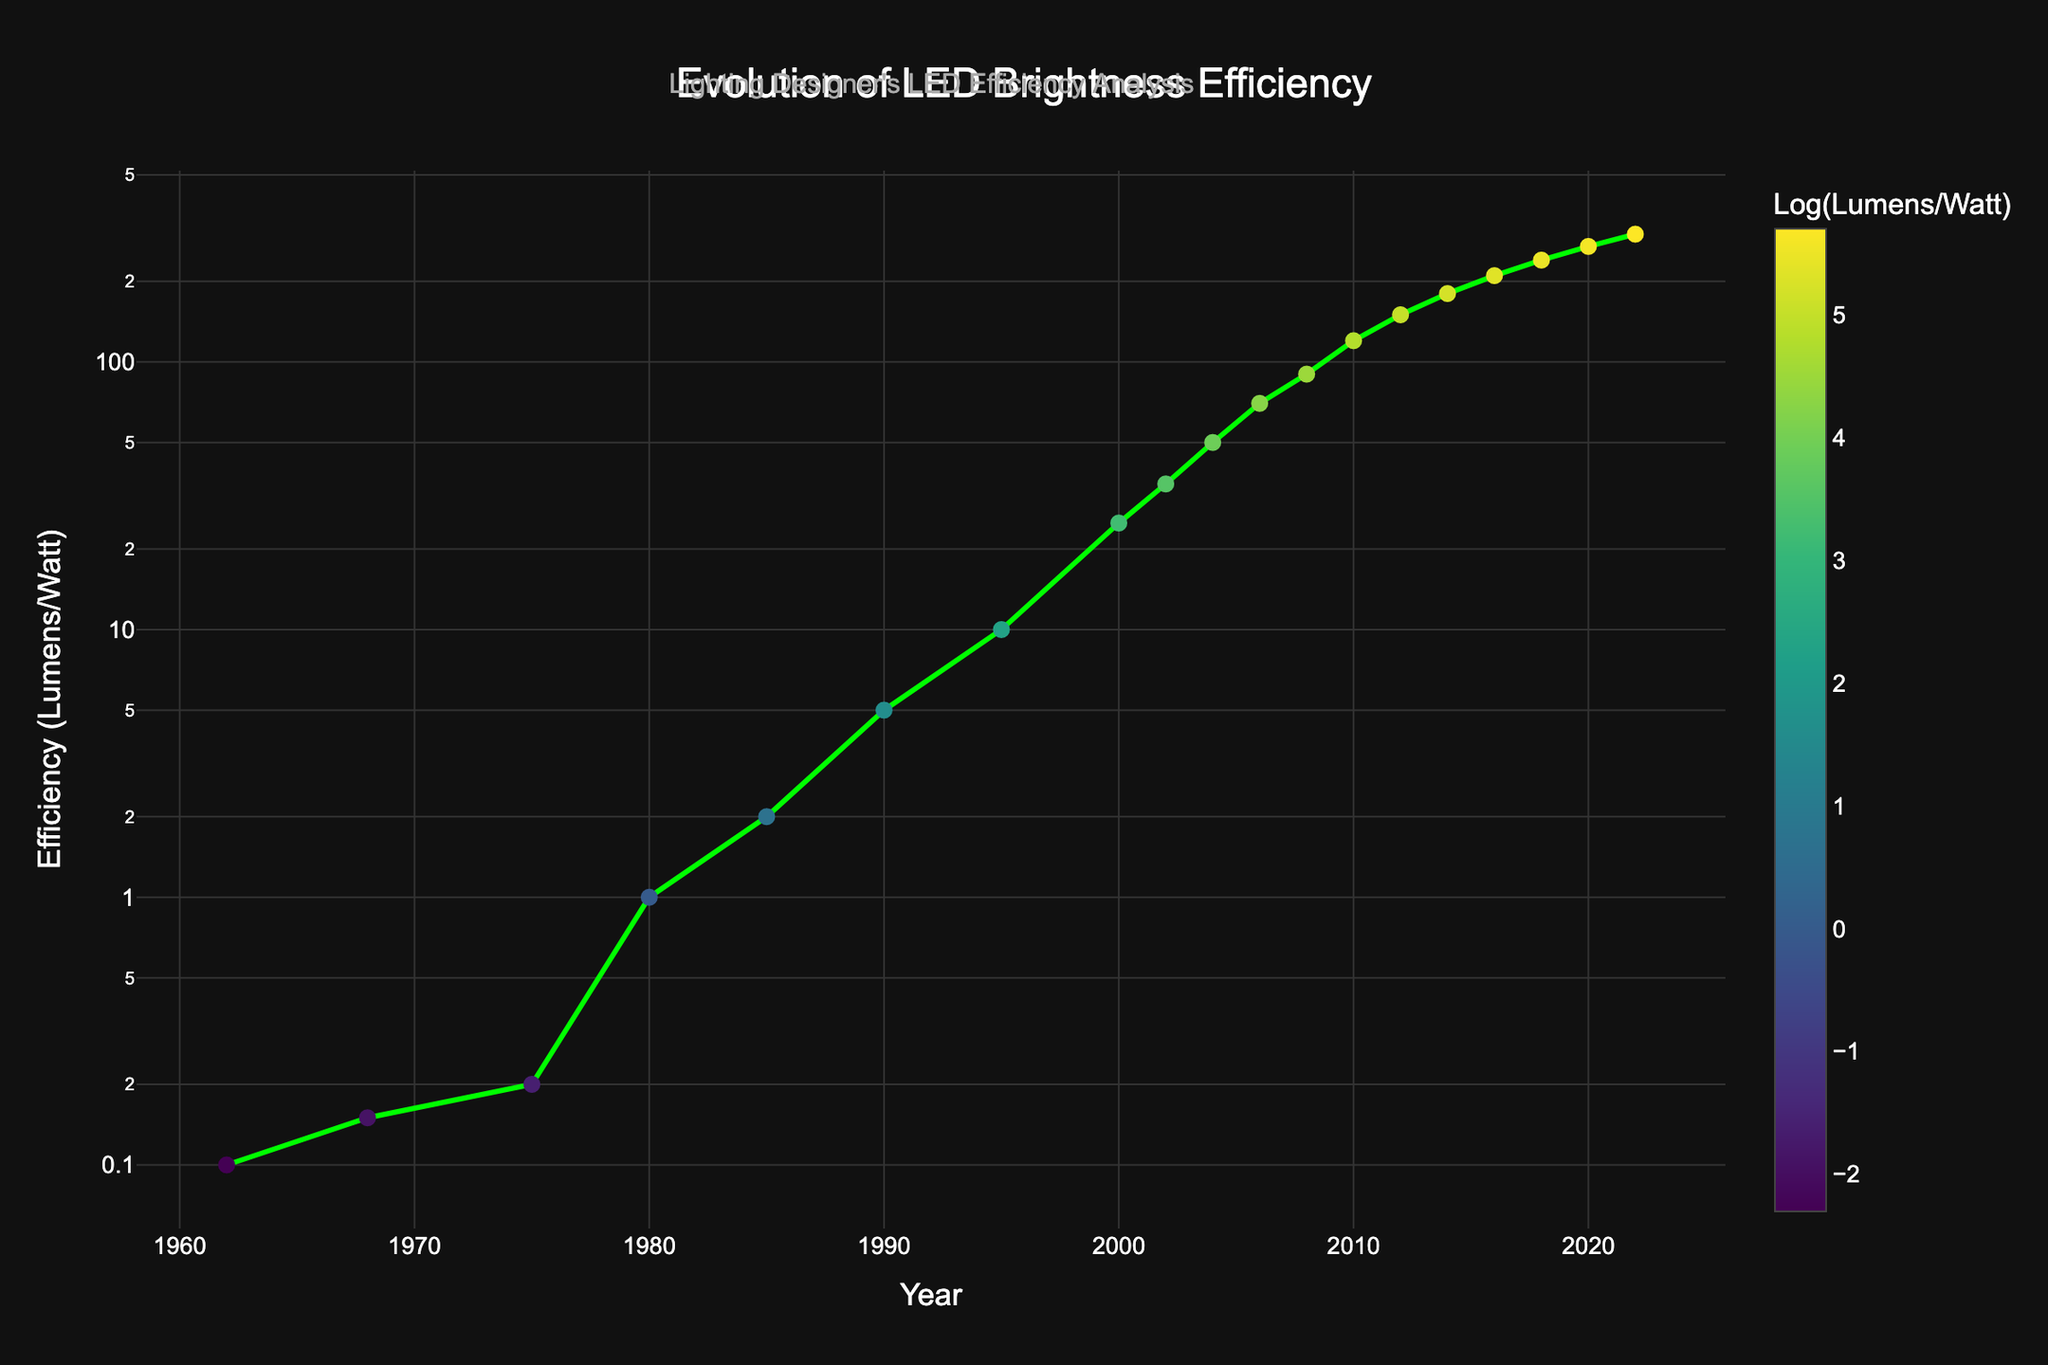What is the efficiency of LED lights in the year 2010? Locate the year 2010 on the x-axis and find its corresponding value on the y-axis. The plot shows that in 2010, the efficiency is 120 lumens per watt.
Answer: 120 lumens per watt Which year shows the most significant increase in efficiency compared to its previous point? Compare the differences in lumens per watt between consecutive years in the line chart. The most significant increase appears to be between 2000 and 2002, where the efficiency jumps from 25 to 35 lumens per watt.
Answer: 2002 How does the LED efficiency in 1985 compare to that in 1990? Identify the values for 1985 and 1990 on the y-axis. In 1985, the efficiency is 2 lumens per watt; in 1990, it is 5 lumens per watt. Subtract the two values: 5 - 2 = 3, showing an increase of 3 lumens per watt from 1985 to 1990.
Answer: Increase by 3 lumens per watt What is the average LED efficiency for the years 2000, 2010, and 2020? Find the efficiency values for the years 2000, 2010, and 2020. They are 25, 120, and 270 lumens per watt, respectively. Calculate the average: (25 + 120 + 270) / 3 = 415 / 3 = 138.33 lumens per watt.
Answer: 138.33 lumens per watt In which year does the LED efficiency first surpass 100 lumens per watt? Find the first point on the y-axis where the lumens per watt exceed 100. The plot shows that in 2008, the efficiency is 90 lumens per watt, and in 2010, it is 120 lumens per watt. Therefore, 2010 is the first year it surpasses 100 lumens per watt.
Answer: 2010 By how much did the efficiency increase between 2012 and 2016? Identify the efficiency values for 2012 and 2016. In 2012, it is 150 lumens per watt, and in 2016, it is 210 lumens per watt. Subtract the two values: 210 - 150 = 60 lumens per watt.
Answer: 60 lumens per watt Is there a year where the efficiency exactly doubles from a previous year? Check the values year by year to see if any year’s efficiency is exactly twice that of a previous year. It is not exactly doubled in any year based on the given data.
Answer: No What is the median efficiency value for the years listed? Order the efficiency values: 0.1, 0.15, 0.2, 1, 2, 5, 10, 25, 35, 50, 70, 90, 120, 150, 180, 210, 240, 270, 300. The median is the middle value in the ordered list. In this case, the 10th value, 50 lumens per watt, is the median.
Answer: 50 lumens per watt Which year had the smallest efficiency value, and what was it? Scan the y-axis values and identify the smallest one, which is 0.1 lumens per watt in 1962.
Answer: 1962, 0.1 lumens per watt 